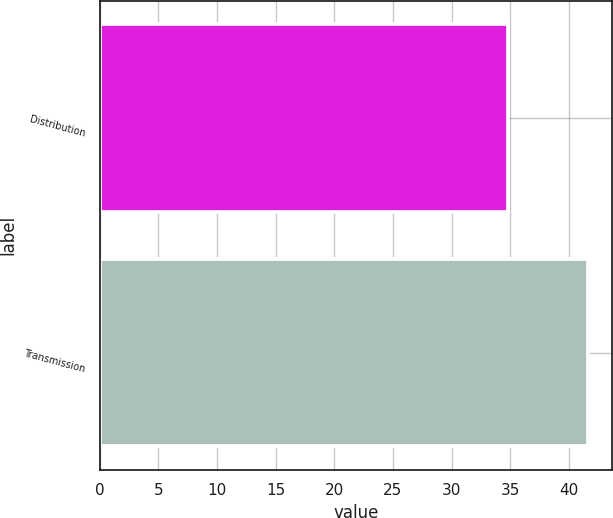Convert chart to OTSL. <chart><loc_0><loc_0><loc_500><loc_500><bar_chart><fcel>Distribution<fcel>Transmission<nl><fcel>34.8<fcel>41.6<nl></chart> 